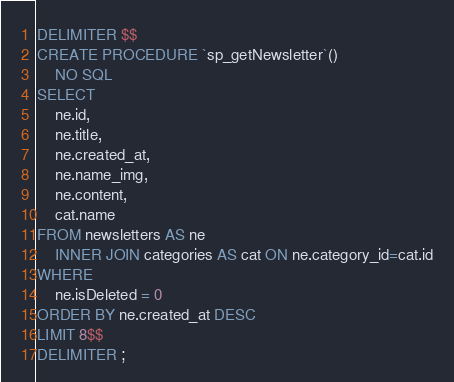Convert code to text. <code><loc_0><loc_0><loc_500><loc_500><_SQL_>DELIMITER $$
CREATE PROCEDURE `sp_getNewsletter`()
    NO SQL
SELECT 
	ne.id,
    ne.title,
    ne.created_at,
    ne.name_img,
    ne.content,
    cat.name
FROM newsletters AS ne 
	INNER JOIN categories AS cat ON ne.category_id=cat.id
WHERE 
	ne.isDeleted = 0 
ORDER BY ne.created_at DESC
LIMIT 8$$
DELIMITER ;</code> 